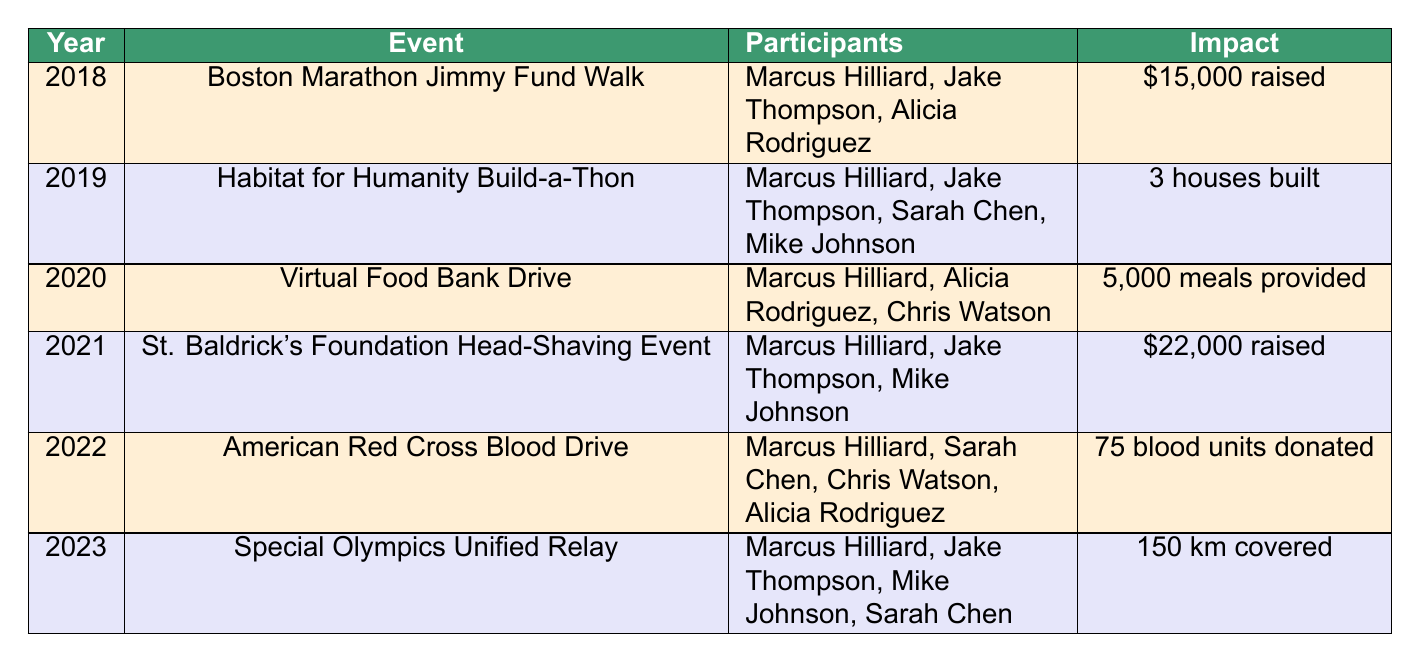What event raised the most funds? In the table, the most funds raised is listed under the "St. Baldrick's Foundation Head-Shaving Event" from the year 2021, where \$22,000 was raised.
Answer: St. Baldrick's Foundation Head-Shaving Event How many houses were built during the Habitat for Humanity Build-a-Thon? The table indicates that during the 2019 Habitat for Humanity Build-a-Thon, 3 houses were built.
Answer: 3 houses Did Marcus Hilliard participate in the Virtual Food Bank Drive? The data shows that Marcus Hilliard was indeed one of the participants in the Virtual Food Bank Drive in 2020.
Answer: Yes Which event had the highest number of participants? The event with the most participants is the Habitat for Humanity Build-a-Thon in 2019, which had 4 participants: Marcus Hilliard, Jake Thompson, Sarah Chen, and Mike Johnson.
Answer: Habitat for Humanity Build-a-Thon What is the total amount of funds raised in 2018 and 2021 combined? The amount raised in 2018 for the Boston Marathon Jimmy Fund Walk was \$15,000, and in 2021 for the St. Baldrick's Event, it was \$22,000. Adding these amounts gives \$15,000 + \$22,000 = \$37,000.
Answer: \$37,000 How many meals were provided in 2020? According to the table, the Virtual Food Bank Drive in 2020 provided 5,000 meals.
Answer: 5,000 meals Which events involved Jake Thompson? Jake Thompson participated in the Boston Marathon Jimmy Fund Walk in 2018, Habitat for Humanity Build-a-Thon in 2019, St. Baldrick's Foundation Head-Shaving Event in 2021, and the Special Olympics Unified Relay in 2023.
Answer: 4 events In which year were most participants involved with Marcus Hilliard? The year with the most participants involved with Marcus Hilliard was 2019, with 4 participants in the Habitat for Humanity Build-a-Thon.
Answer: 2019 What was the total distance covered in the Special Olympics Unified Relay? The table lists 150 km as the total distance covered in the Special Olympics Unified Relay in 2023.
Answer: 150 km Was there a blood drive event? Yes, the American Red Cross Blood Drive event occurred in 2022, and Marcus Hilliard participated.
Answer: Yes 